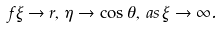<formula> <loc_0><loc_0><loc_500><loc_500>f \xi \rightarrow r , \, \eta \rightarrow \cos \theta , \, a s \, \xi \rightarrow \infty .</formula> 